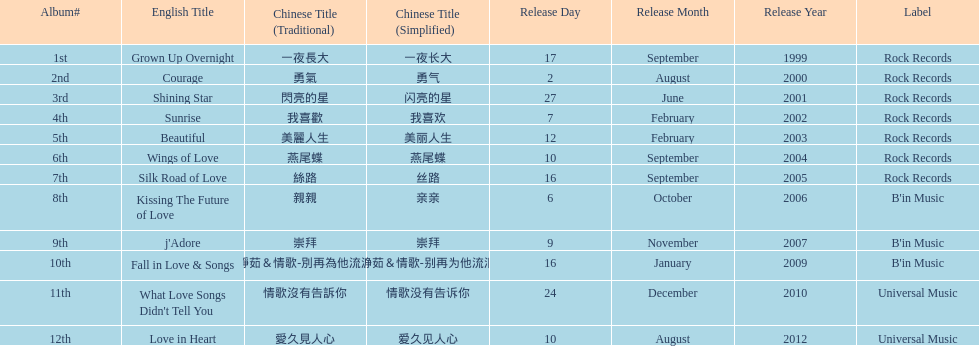What is the name of her last album produced with rock records? Silk Road of Love. 